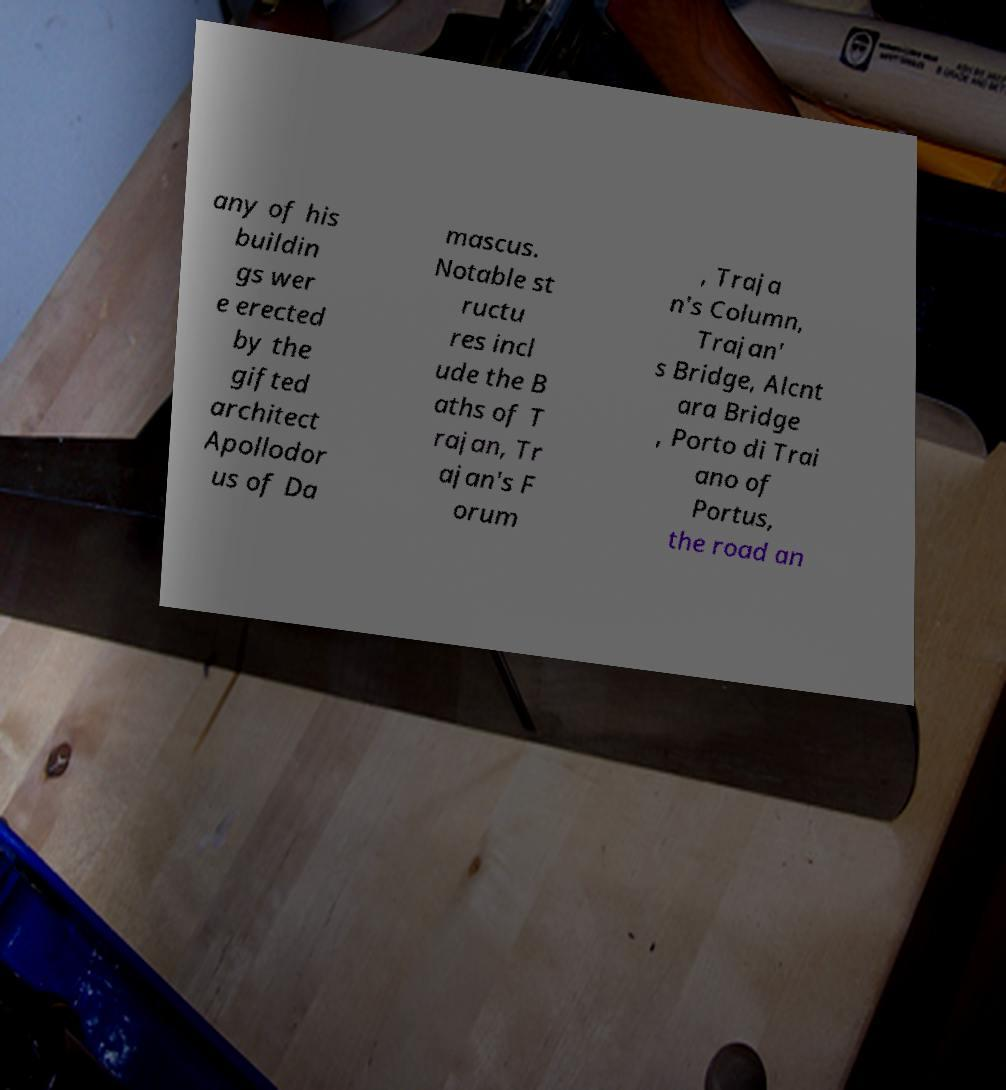I need the written content from this picture converted into text. Can you do that? any of his buildin gs wer e erected by the gifted architect Apollodor us of Da mascus. Notable st ructu res incl ude the B aths of T rajan, Tr ajan's F orum , Traja n's Column, Trajan' s Bridge, Alcnt ara Bridge , Porto di Trai ano of Portus, the road an 